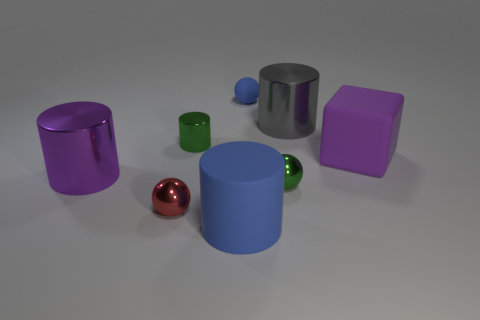Subtract all rubber spheres. How many spheres are left? 2 Add 2 purple matte cylinders. How many objects exist? 10 Subtract all gray cylinders. How many cylinders are left? 3 Subtract 1 cylinders. How many cylinders are left? 3 Subtract all blocks. How many objects are left? 7 Subtract all gray cubes. How many green balls are left? 1 Subtract all metal objects. Subtract all small rubber objects. How many objects are left? 2 Add 3 small shiny objects. How many small shiny objects are left? 6 Add 6 tiny yellow rubber cylinders. How many tiny yellow rubber cylinders exist? 6 Subtract 0 yellow spheres. How many objects are left? 8 